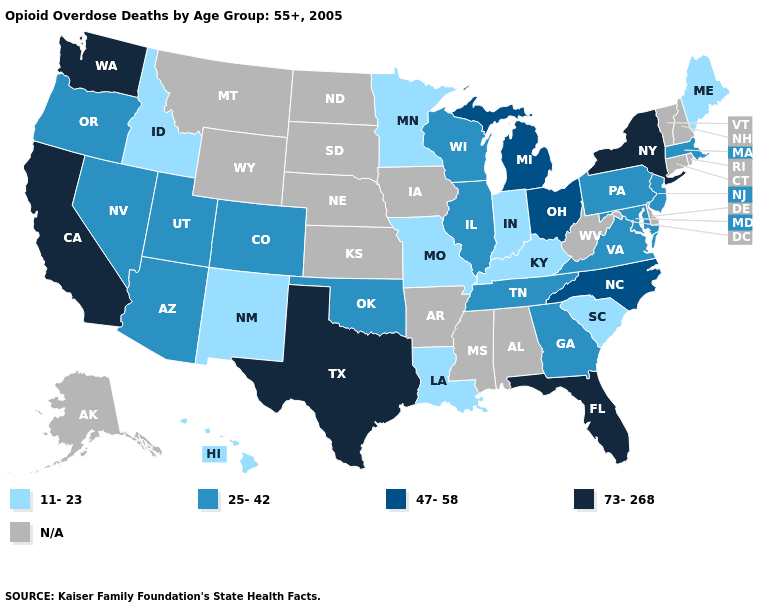Name the states that have a value in the range N/A?
Answer briefly. Alabama, Alaska, Arkansas, Connecticut, Delaware, Iowa, Kansas, Mississippi, Montana, Nebraska, New Hampshire, North Dakota, Rhode Island, South Dakota, Vermont, West Virginia, Wyoming. Name the states that have a value in the range 47-58?
Be succinct. Michigan, North Carolina, Ohio. Name the states that have a value in the range N/A?
Concise answer only. Alabama, Alaska, Arkansas, Connecticut, Delaware, Iowa, Kansas, Mississippi, Montana, Nebraska, New Hampshire, North Dakota, Rhode Island, South Dakota, Vermont, West Virginia, Wyoming. Name the states that have a value in the range N/A?
Answer briefly. Alabama, Alaska, Arkansas, Connecticut, Delaware, Iowa, Kansas, Mississippi, Montana, Nebraska, New Hampshire, North Dakota, Rhode Island, South Dakota, Vermont, West Virginia, Wyoming. Is the legend a continuous bar?
Write a very short answer. No. What is the value of Nebraska?
Write a very short answer. N/A. What is the value of Maryland?
Write a very short answer. 25-42. What is the highest value in the Northeast ?
Quick response, please. 73-268. Which states have the lowest value in the USA?
Give a very brief answer. Hawaii, Idaho, Indiana, Kentucky, Louisiana, Maine, Minnesota, Missouri, New Mexico, South Carolina. Does Kentucky have the lowest value in the USA?
Answer briefly. Yes. What is the value of Rhode Island?
Short answer required. N/A. Name the states that have a value in the range 73-268?
Give a very brief answer. California, Florida, New York, Texas, Washington. Name the states that have a value in the range 25-42?
Give a very brief answer. Arizona, Colorado, Georgia, Illinois, Maryland, Massachusetts, Nevada, New Jersey, Oklahoma, Oregon, Pennsylvania, Tennessee, Utah, Virginia, Wisconsin. What is the value of Oklahoma?
Write a very short answer. 25-42. 